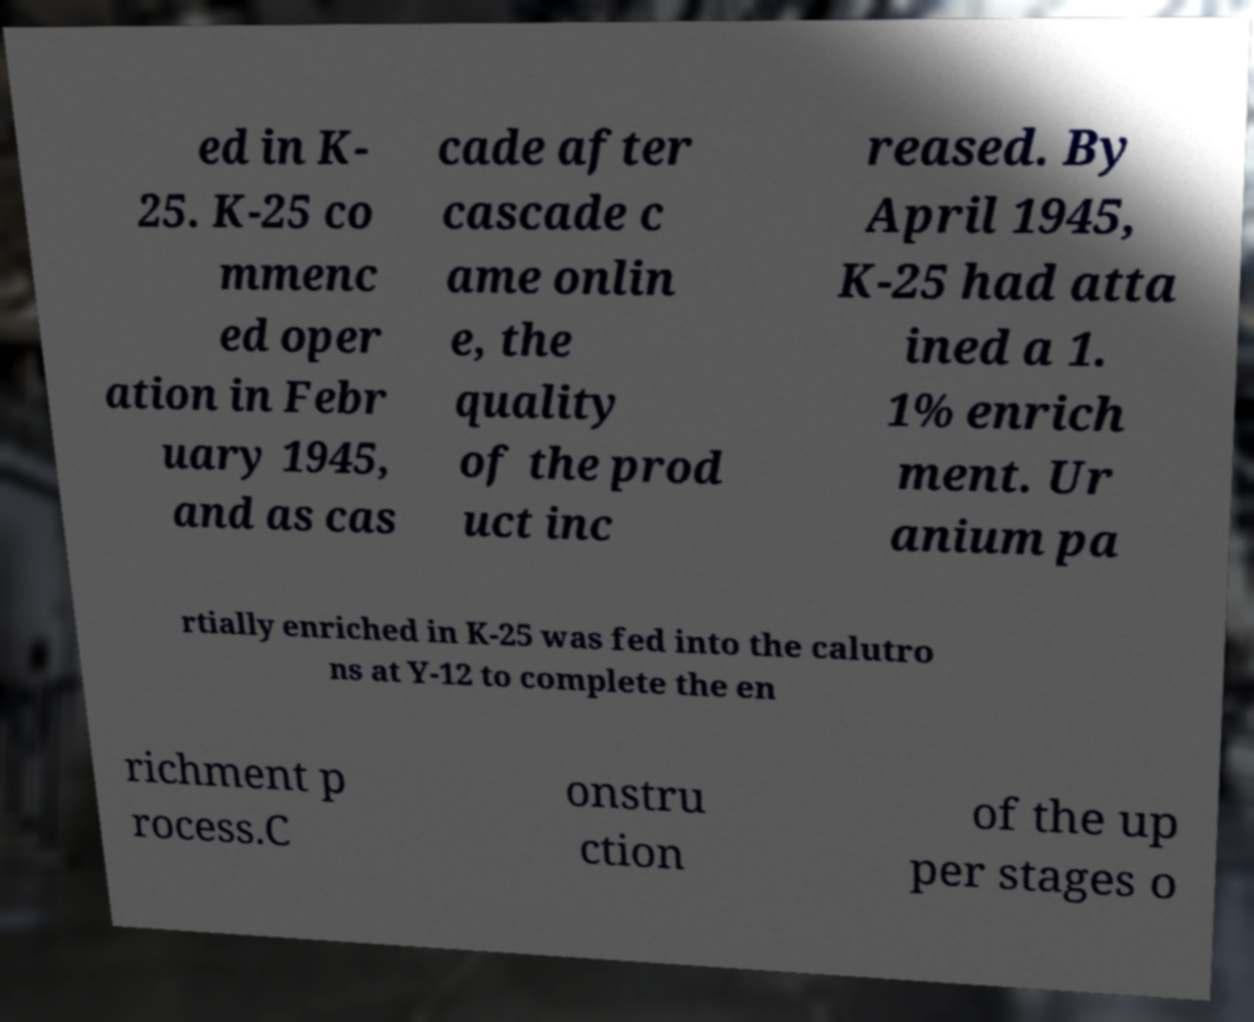Could you extract and type out the text from this image? ed in K- 25. K-25 co mmenc ed oper ation in Febr uary 1945, and as cas cade after cascade c ame onlin e, the quality of the prod uct inc reased. By April 1945, K-25 had atta ined a 1. 1% enrich ment. Ur anium pa rtially enriched in K-25 was fed into the calutro ns at Y-12 to complete the en richment p rocess.C onstru ction of the up per stages o 